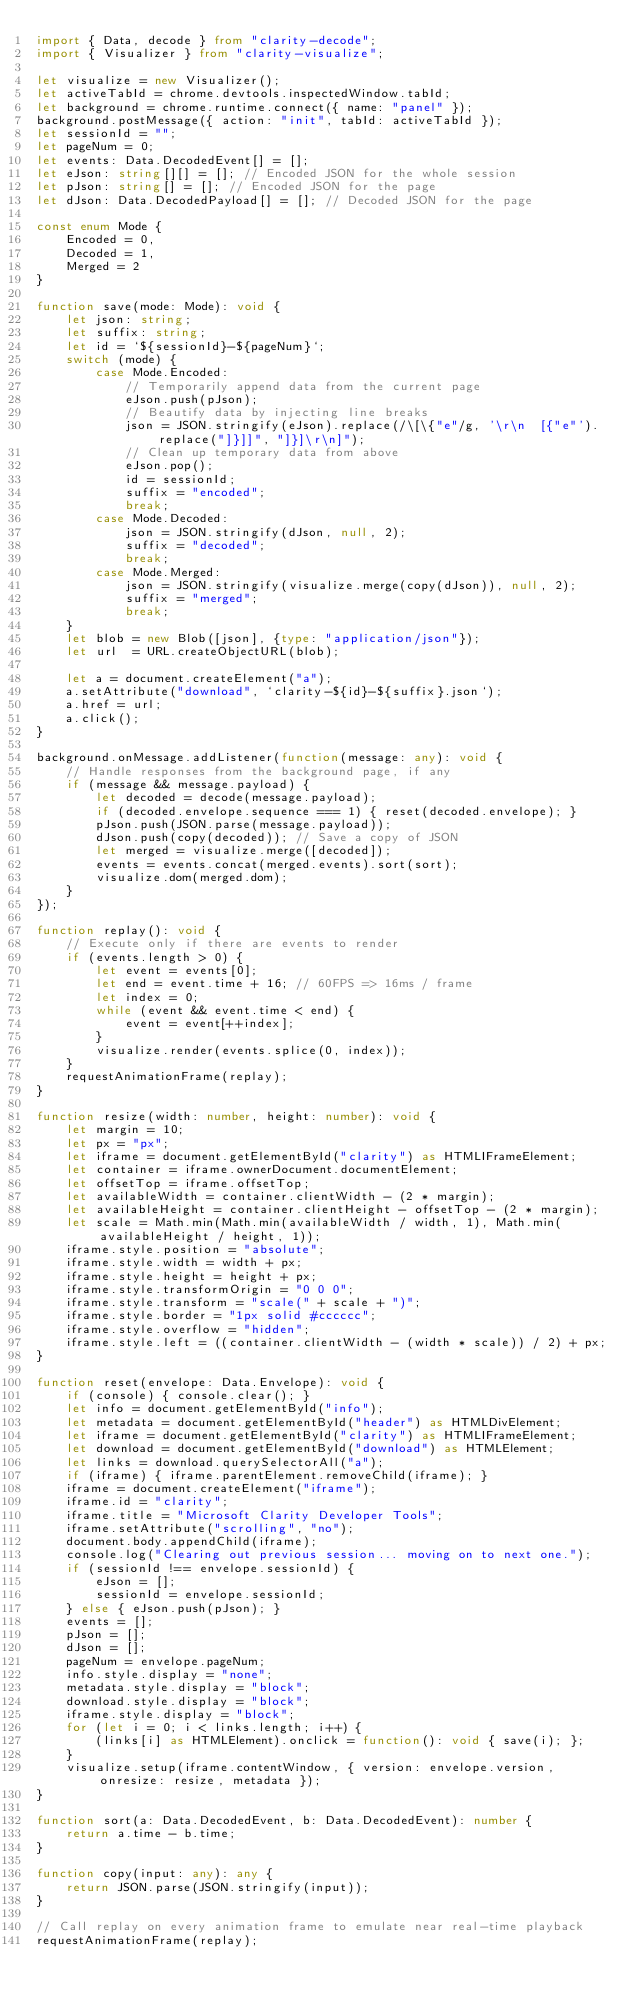<code> <loc_0><loc_0><loc_500><loc_500><_TypeScript_>import { Data, decode } from "clarity-decode";
import { Visualizer } from "clarity-visualize";

let visualize = new Visualizer();
let activeTabId = chrome.devtools.inspectedWindow.tabId;
let background = chrome.runtime.connect({ name: "panel" });
background.postMessage({ action: "init", tabId: activeTabId });
let sessionId = "";
let pageNum = 0;
let events: Data.DecodedEvent[] = [];
let eJson: string[][] = []; // Encoded JSON for the whole session
let pJson: string[] = []; // Encoded JSON for the page
let dJson: Data.DecodedPayload[] = []; // Decoded JSON for the page

const enum Mode {
    Encoded = 0,
    Decoded = 1,
    Merged = 2
}

function save(mode: Mode): void {
    let json: string;
    let suffix: string;
    let id = `${sessionId}-${pageNum}`;
    switch (mode) {
        case Mode.Encoded:
            // Temporarily append data from the current page
            eJson.push(pJson);
            // Beautify data by injecting line breaks
            json = JSON.stringify(eJson).replace(/\[\{"e"/g, '\r\n  [{"e"').replace("]}]]", "]}]\r\n]");
            // Clean up temporary data from above
            eJson.pop();
            id = sessionId;
            suffix = "encoded";
            break;
        case Mode.Decoded:
            json = JSON.stringify(dJson, null, 2);
            suffix = "decoded";
            break;
        case Mode.Merged:
            json = JSON.stringify(visualize.merge(copy(dJson)), null, 2);
            suffix = "merged";
            break;
    }
    let blob = new Blob([json], {type: "application/json"});
    let url  = URL.createObjectURL(blob);

    let a = document.createElement("a");
    a.setAttribute("download", `clarity-${id}-${suffix}.json`);
    a.href = url;
    a.click();
}

background.onMessage.addListener(function(message: any): void {
    // Handle responses from the background page, if any
    if (message && message.payload) {
        let decoded = decode(message.payload);
        if (decoded.envelope.sequence === 1) { reset(decoded.envelope); }
        pJson.push(JSON.parse(message.payload));
        dJson.push(copy(decoded)); // Save a copy of JSON
        let merged = visualize.merge([decoded]);
        events = events.concat(merged.events).sort(sort);
        visualize.dom(merged.dom);
    }
});

function replay(): void {
    // Execute only if there are events to render
    if (events.length > 0) {
        let event = events[0];
        let end = event.time + 16; // 60FPS => 16ms / frame
        let index = 0;
        while (event && event.time < end) {
            event = event[++index];
        }
        visualize.render(events.splice(0, index));
    }
    requestAnimationFrame(replay);
}

function resize(width: number, height: number): void {
    let margin = 10;
    let px = "px";
    let iframe = document.getElementById("clarity") as HTMLIFrameElement;
    let container = iframe.ownerDocument.documentElement;
    let offsetTop = iframe.offsetTop;
    let availableWidth = container.clientWidth - (2 * margin);
    let availableHeight = container.clientHeight - offsetTop - (2 * margin);
    let scale = Math.min(Math.min(availableWidth / width, 1), Math.min(availableHeight / height, 1));
    iframe.style.position = "absolute";
    iframe.style.width = width + px;
    iframe.style.height = height + px;
    iframe.style.transformOrigin = "0 0 0";
    iframe.style.transform = "scale(" + scale + ")";
    iframe.style.border = "1px solid #cccccc";
    iframe.style.overflow = "hidden";
    iframe.style.left = ((container.clientWidth - (width * scale)) / 2) + px;
}

function reset(envelope: Data.Envelope): void {
    if (console) { console.clear(); }
    let info = document.getElementById("info");
    let metadata = document.getElementById("header") as HTMLDivElement;
    let iframe = document.getElementById("clarity") as HTMLIFrameElement;
    let download = document.getElementById("download") as HTMLElement;
    let links = download.querySelectorAll("a");
    if (iframe) { iframe.parentElement.removeChild(iframe); }
    iframe = document.createElement("iframe");
    iframe.id = "clarity";
    iframe.title = "Microsoft Clarity Developer Tools";
    iframe.setAttribute("scrolling", "no");
    document.body.appendChild(iframe);
    console.log("Clearing out previous session... moving on to next one.");
    if (sessionId !== envelope.sessionId) {
        eJson = [];
        sessionId = envelope.sessionId;
    } else { eJson.push(pJson); }
    events = [];
    pJson = [];
    dJson = [];
    pageNum = envelope.pageNum;
    info.style.display = "none";
    metadata.style.display = "block";
    download.style.display = "block";
    iframe.style.display = "block";
    for (let i = 0; i < links.length; i++) {
        (links[i] as HTMLElement).onclick = function(): void { save(i); };
    }
    visualize.setup(iframe.contentWindow, { version: envelope.version, onresize: resize, metadata });
}

function sort(a: Data.DecodedEvent, b: Data.DecodedEvent): number {
    return a.time - b.time;
}

function copy(input: any): any {
    return JSON.parse(JSON.stringify(input));
}

// Call replay on every animation frame to emulate near real-time playback
requestAnimationFrame(replay);
</code> 